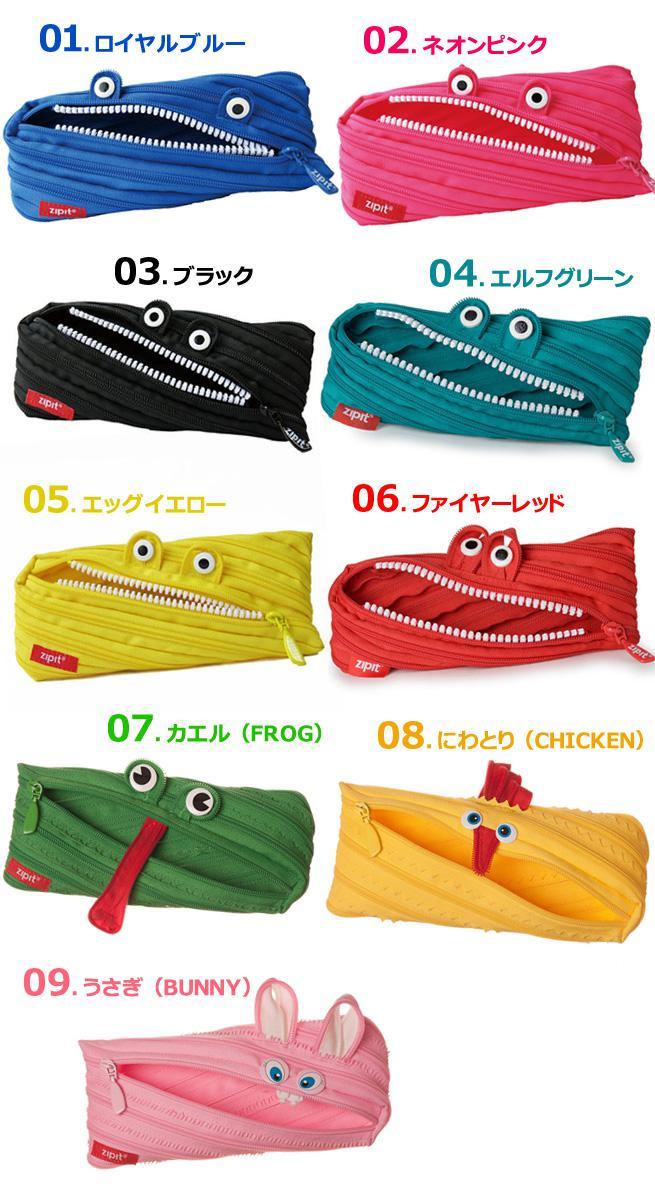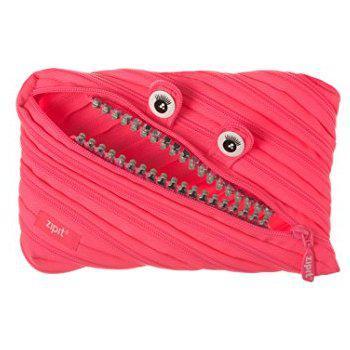The first image is the image on the left, the second image is the image on the right. Considering the images on both sides, is "There is a single pink bag in the image on the left." valid? Answer yes or no. No. 